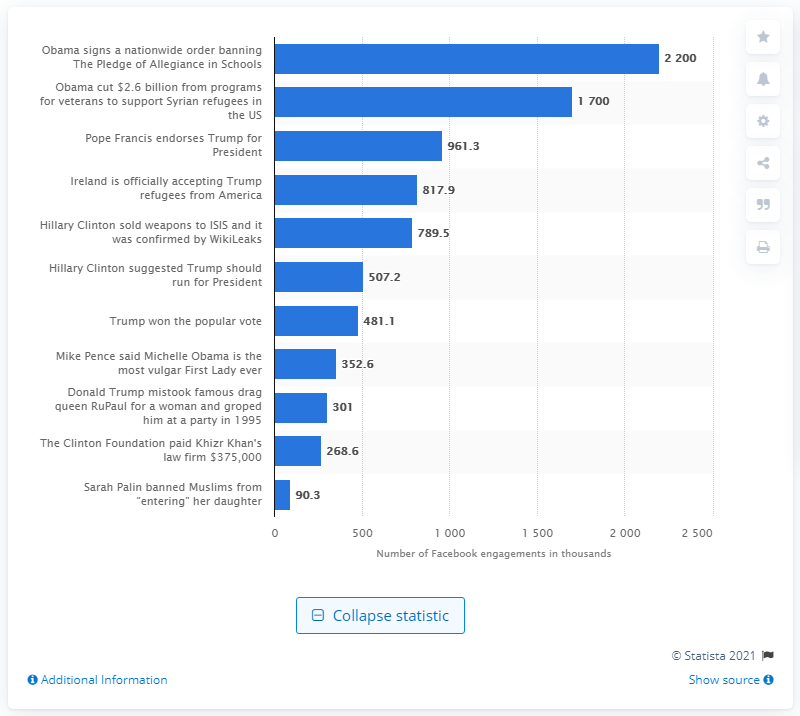Point out several critical features in this image. The fake news story was shared on Facebook a total of 2,200 times in the three months leading up to the election. 